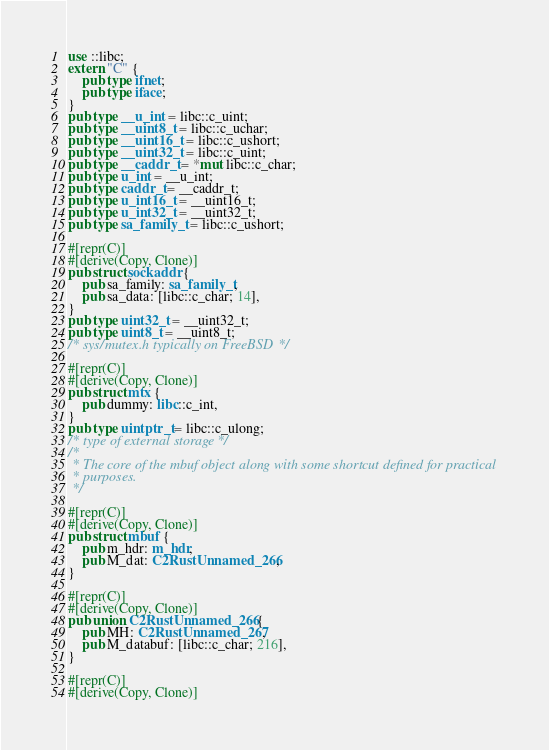<code> <loc_0><loc_0><loc_500><loc_500><_Rust_>use ::libc;
extern "C" {
    pub type ifnet;
    pub type iface;
}
pub type __u_int = libc::c_uint;
pub type __uint8_t = libc::c_uchar;
pub type __uint16_t = libc::c_ushort;
pub type __uint32_t = libc::c_uint;
pub type __caddr_t = *mut libc::c_char;
pub type u_int = __u_int;
pub type caddr_t = __caddr_t;
pub type u_int16_t = __uint16_t;
pub type u_int32_t = __uint32_t;
pub type sa_family_t = libc::c_ushort;

#[repr(C)]
#[derive(Copy, Clone)]
pub struct sockaddr {
    pub sa_family: sa_family_t,
    pub sa_data: [libc::c_char; 14],
}
pub type uint32_t = __uint32_t;
pub type uint8_t = __uint8_t;
/* sys/mutex.h typically on FreeBSD */

#[repr(C)]
#[derive(Copy, Clone)]
pub struct mtx {
    pub dummy: libc::c_int,
}
pub type uintptr_t = libc::c_ulong;
/* type of external storage */
/*
 * The core of the mbuf object along with some shortcut defined for practical
 * purposes.
 */

#[repr(C)]
#[derive(Copy, Clone)]
pub struct mbuf {
    pub m_hdr: m_hdr,
    pub M_dat: C2RustUnnamed_266,
}

#[repr(C)]
#[derive(Copy, Clone)]
pub union C2RustUnnamed_266 {
    pub MH: C2RustUnnamed_267,
    pub M_databuf: [libc::c_char; 216],
}

#[repr(C)]
#[derive(Copy, Clone)]</code> 